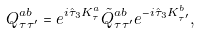Convert formula to latex. <formula><loc_0><loc_0><loc_500><loc_500>Q ^ { a b } _ { \tau \tau ^ { \prime } } = e ^ { i \hat { \tau } _ { 3 } K ^ { a } _ { \tau } } \tilde { Q } ^ { a b } _ { \tau \tau ^ { \prime } } e ^ { - i \hat { \tau } _ { 3 } K ^ { b } _ { \tau ^ { \prime } } } ,</formula> 